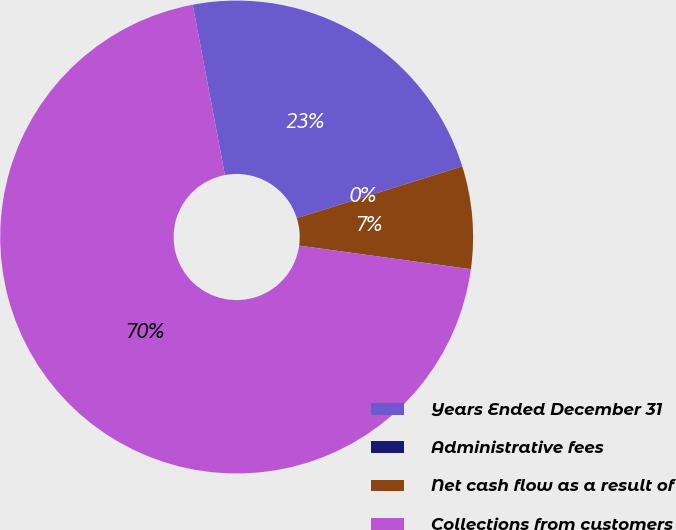Convert chart to OTSL. <chart><loc_0><loc_0><loc_500><loc_500><pie_chart><fcel>Years Ended December 31<fcel>Administrative fees<fcel>Net cash flow as a result of<fcel>Collections from customers<nl><fcel>23.14%<fcel>0.01%<fcel>7.0%<fcel>69.85%<nl></chart> 